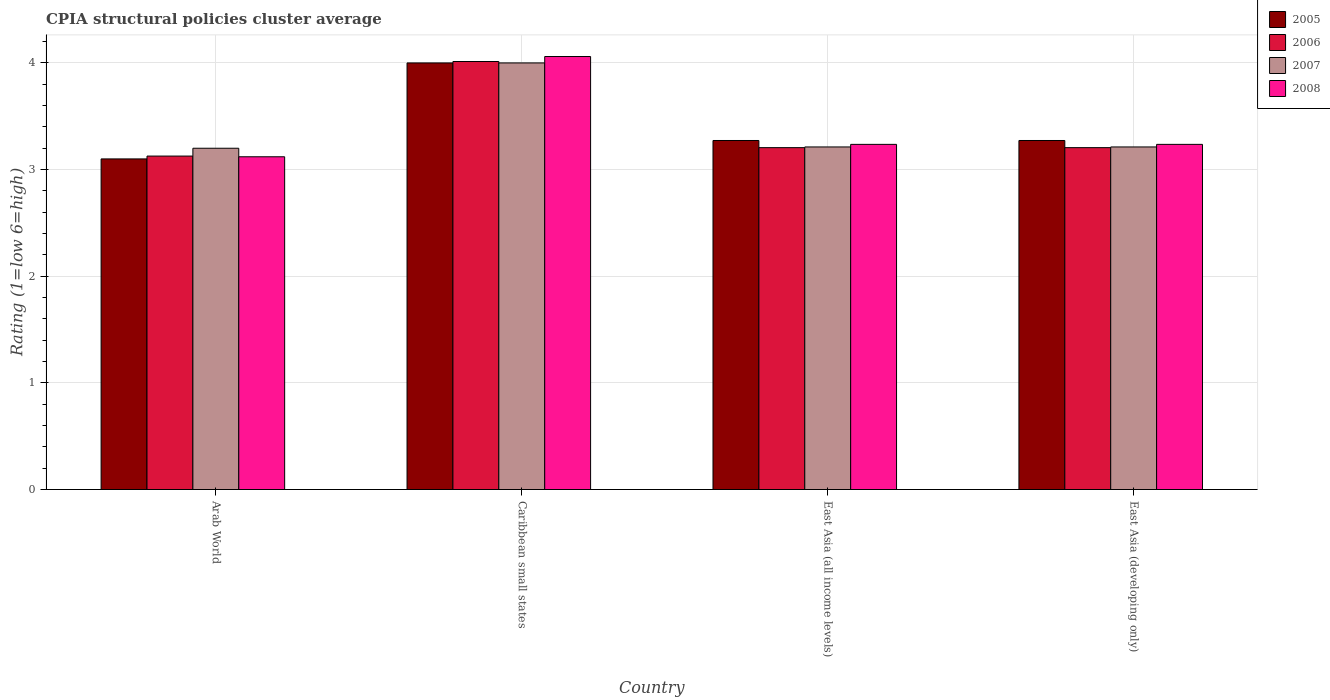How many groups of bars are there?
Ensure brevity in your answer.  4. Are the number of bars per tick equal to the number of legend labels?
Make the answer very short. Yes. Are the number of bars on each tick of the X-axis equal?
Your answer should be very brief. Yes. How many bars are there on the 3rd tick from the right?
Make the answer very short. 4. What is the label of the 2nd group of bars from the left?
Your response must be concise. Caribbean small states. In how many cases, is the number of bars for a given country not equal to the number of legend labels?
Your answer should be very brief. 0. What is the CPIA rating in 2008 in Arab World?
Give a very brief answer. 3.12. Across all countries, what is the maximum CPIA rating in 2007?
Offer a very short reply. 4. Across all countries, what is the minimum CPIA rating in 2006?
Your answer should be very brief. 3.13. In which country was the CPIA rating in 2007 maximum?
Your answer should be very brief. Caribbean small states. In which country was the CPIA rating in 2005 minimum?
Your answer should be compact. Arab World. What is the total CPIA rating in 2007 in the graph?
Give a very brief answer. 13.62. What is the difference between the CPIA rating in 2005 in East Asia (all income levels) and that in East Asia (developing only)?
Keep it short and to the point. 0. What is the difference between the CPIA rating in 2007 in Arab World and the CPIA rating in 2006 in Caribbean small states?
Give a very brief answer. -0.81. What is the average CPIA rating in 2008 per country?
Offer a terse response. 3.41. What is the difference between the CPIA rating of/in 2008 and CPIA rating of/in 2007 in Caribbean small states?
Your answer should be compact. 0.06. What is the ratio of the CPIA rating in 2006 in Caribbean small states to that in East Asia (all income levels)?
Your response must be concise. 1.25. Is the CPIA rating in 2005 in Arab World less than that in East Asia (developing only)?
Your answer should be compact. Yes. Is the difference between the CPIA rating in 2008 in Arab World and East Asia (all income levels) greater than the difference between the CPIA rating in 2007 in Arab World and East Asia (all income levels)?
Your response must be concise. No. What is the difference between the highest and the second highest CPIA rating in 2007?
Provide a short and direct response. -0.79. What is the difference between the highest and the lowest CPIA rating in 2005?
Provide a succinct answer. 0.9. Is it the case that in every country, the sum of the CPIA rating in 2008 and CPIA rating in 2006 is greater than the CPIA rating in 2007?
Your answer should be compact. Yes. How many bars are there?
Your answer should be compact. 16. What is the difference between two consecutive major ticks on the Y-axis?
Provide a succinct answer. 1. Are the values on the major ticks of Y-axis written in scientific E-notation?
Ensure brevity in your answer.  No. Does the graph contain any zero values?
Your answer should be compact. No. Does the graph contain grids?
Keep it short and to the point. Yes. Where does the legend appear in the graph?
Give a very brief answer. Top right. How many legend labels are there?
Give a very brief answer. 4. What is the title of the graph?
Your answer should be compact. CPIA structural policies cluster average. What is the label or title of the Y-axis?
Your answer should be compact. Rating (1=low 6=high). What is the Rating (1=low 6=high) of 2006 in Arab World?
Give a very brief answer. 3.13. What is the Rating (1=low 6=high) of 2008 in Arab World?
Offer a terse response. 3.12. What is the Rating (1=low 6=high) of 2005 in Caribbean small states?
Your answer should be compact. 4. What is the Rating (1=low 6=high) of 2006 in Caribbean small states?
Your response must be concise. 4.01. What is the Rating (1=low 6=high) of 2007 in Caribbean small states?
Provide a succinct answer. 4. What is the Rating (1=low 6=high) in 2008 in Caribbean small states?
Your answer should be very brief. 4.06. What is the Rating (1=low 6=high) of 2005 in East Asia (all income levels)?
Offer a very short reply. 3.27. What is the Rating (1=low 6=high) in 2006 in East Asia (all income levels)?
Provide a succinct answer. 3.21. What is the Rating (1=low 6=high) of 2007 in East Asia (all income levels)?
Offer a very short reply. 3.21. What is the Rating (1=low 6=high) in 2008 in East Asia (all income levels)?
Keep it short and to the point. 3.24. What is the Rating (1=low 6=high) in 2005 in East Asia (developing only)?
Ensure brevity in your answer.  3.27. What is the Rating (1=low 6=high) in 2006 in East Asia (developing only)?
Ensure brevity in your answer.  3.21. What is the Rating (1=low 6=high) of 2007 in East Asia (developing only)?
Provide a short and direct response. 3.21. What is the Rating (1=low 6=high) in 2008 in East Asia (developing only)?
Your answer should be compact. 3.24. Across all countries, what is the maximum Rating (1=low 6=high) in 2006?
Keep it short and to the point. 4.01. Across all countries, what is the maximum Rating (1=low 6=high) in 2008?
Ensure brevity in your answer.  4.06. Across all countries, what is the minimum Rating (1=low 6=high) of 2005?
Offer a very short reply. 3.1. Across all countries, what is the minimum Rating (1=low 6=high) in 2006?
Your answer should be very brief. 3.13. Across all countries, what is the minimum Rating (1=low 6=high) of 2007?
Ensure brevity in your answer.  3.2. Across all countries, what is the minimum Rating (1=low 6=high) in 2008?
Your response must be concise. 3.12. What is the total Rating (1=low 6=high) of 2005 in the graph?
Provide a short and direct response. 13.65. What is the total Rating (1=low 6=high) in 2006 in the graph?
Offer a terse response. 13.55. What is the total Rating (1=low 6=high) in 2007 in the graph?
Offer a very short reply. 13.62. What is the total Rating (1=low 6=high) of 2008 in the graph?
Provide a succinct answer. 13.65. What is the difference between the Rating (1=low 6=high) in 2005 in Arab World and that in Caribbean small states?
Offer a terse response. -0.9. What is the difference between the Rating (1=low 6=high) of 2006 in Arab World and that in Caribbean small states?
Make the answer very short. -0.89. What is the difference between the Rating (1=low 6=high) of 2007 in Arab World and that in Caribbean small states?
Provide a short and direct response. -0.8. What is the difference between the Rating (1=low 6=high) of 2008 in Arab World and that in Caribbean small states?
Provide a short and direct response. -0.94. What is the difference between the Rating (1=low 6=high) in 2005 in Arab World and that in East Asia (all income levels)?
Give a very brief answer. -0.17. What is the difference between the Rating (1=low 6=high) of 2006 in Arab World and that in East Asia (all income levels)?
Offer a very short reply. -0.08. What is the difference between the Rating (1=low 6=high) in 2007 in Arab World and that in East Asia (all income levels)?
Ensure brevity in your answer.  -0.01. What is the difference between the Rating (1=low 6=high) of 2008 in Arab World and that in East Asia (all income levels)?
Give a very brief answer. -0.12. What is the difference between the Rating (1=low 6=high) of 2005 in Arab World and that in East Asia (developing only)?
Provide a short and direct response. -0.17. What is the difference between the Rating (1=low 6=high) in 2006 in Arab World and that in East Asia (developing only)?
Make the answer very short. -0.08. What is the difference between the Rating (1=low 6=high) in 2007 in Arab World and that in East Asia (developing only)?
Provide a short and direct response. -0.01. What is the difference between the Rating (1=low 6=high) in 2008 in Arab World and that in East Asia (developing only)?
Your answer should be very brief. -0.12. What is the difference between the Rating (1=low 6=high) in 2005 in Caribbean small states and that in East Asia (all income levels)?
Make the answer very short. 0.73. What is the difference between the Rating (1=low 6=high) in 2006 in Caribbean small states and that in East Asia (all income levels)?
Your response must be concise. 0.81. What is the difference between the Rating (1=low 6=high) of 2007 in Caribbean small states and that in East Asia (all income levels)?
Ensure brevity in your answer.  0.79. What is the difference between the Rating (1=low 6=high) in 2008 in Caribbean small states and that in East Asia (all income levels)?
Make the answer very short. 0.82. What is the difference between the Rating (1=low 6=high) of 2005 in Caribbean small states and that in East Asia (developing only)?
Your answer should be compact. 0.73. What is the difference between the Rating (1=low 6=high) in 2006 in Caribbean small states and that in East Asia (developing only)?
Ensure brevity in your answer.  0.81. What is the difference between the Rating (1=low 6=high) of 2007 in Caribbean small states and that in East Asia (developing only)?
Give a very brief answer. 0.79. What is the difference between the Rating (1=low 6=high) of 2008 in Caribbean small states and that in East Asia (developing only)?
Your answer should be compact. 0.82. What is the difference between the Rating (1=low 6=high) in 2005 in East Asia (all income levels) and that in East Asia (developing only)?
Ensure brevity in your answer.  0. What is the difference between the Rating (1=low 6=high) of 2006 in East Asia (all income levels) and that in East Asia (developing only)?
Keep it short and to the point. 0. What is the difference between the Rating (1=low 6=high) of 2007 in East Asia (all income levels) and that in East Asia (developing only)?
Keep it short and to the point. 0. What is the difference between the Rating (1=low 6=high) of 2005 in Arab World and the Rating (1=low 6=high) of 2006 in Caribbean small states?
Provide a short and direct response. -0.91. What is the difference between the Rating (1=low 6=high) of 2005 in Arab World and the Rating (1=low 6=high) of 2007 in Caribbean small states?
Provide a succinct answer. -0.9. What is the difference between the Rating (1=low 6=high) of 2005 in Arab World and the Rating (1=low 6=high) of 2008 in Caribbean small states?
Make the answer very short. -0.96. What is the difference between the Rating (1=low 6=high) of 2006 in Arab World and the Rating (1=low 6=high) of 2007 in Caribbean small states?
Offer a very short reply. -0.87. What is the difference between the Rating (1=low 6=high) of 2006 in Arab World and the Rating (1=low 6=high) of 2008 in Caribbean small states?
Provide a short and direct response. -0.93. What is the difference between the Rating (1=low 6=high) of 2007 in Arab World and the Rating (1=low 6=high) of 2008 in Caribbean small states?
Give a very brief answer. -0.86. What is the difference between the Rating (1=low 6=high) in 2005 in Arab World and the Rating (1=low 6=high) in 2006 in East Asia (all income levels)?
Your answer should be compact. -0.11. What is the difference between the Rating (1=low 6=high) in 2005 in Arab World and the Rating (1=low 6=high) in 2007 in East Asia (all income levels)?
Ensure brevity in your answer.  -0.11. What is the difference between the Rating (1=low 6=high) in 2005 in Arab World and the Rating (1=low 6=high) in 2008 in East Asia (all income levels)?
Give a very brief answer. -0.14. What is the difference between the Rating (1=low 6=high) in 2006 in Arab World and the Rating (1=low 6=high) in 2007 in East Asia (all income levels)?
Make the answer very short. -0.09. What is the difference between the Rating (1=low 6=high) in 2006 in Arab World and the Rating (1=low 6=high) in 2008 in East Asia (all income levels)?
Your answer should be very brief. -0.11. What is the difference between the Rating (1=low 6=high) in 2007 in Arab World and the Rating (1=low 6=high) in 2008 in East Asia (all income levels)?
Offer a terse response. -0.04. What is the difference between the Rating (1=low 6=high) of 2005 in Arab World and the Rating (1=low 6=high) of 2006 in East Asia (developing only)?
Your answer should be compact. -0.11. What is the difference between the Rating (1=low 6=high) in 2005 in Arab World and the Rating (1=low 6=high) in 2007 in East Asia (developing only)?
Offer a terse response. -0.11. What is the difference between the Rating (1=low 6=high) of 2005 in Arab World and the Rating (1=low 6=high) of 2008 in East Asia (developing only)?
Your answer should be very brief. -0.14. What is the difference between the Rating (1=low 6=high) in 2006 in Arab World and the Rating (1=low 6=high) in 2007 in East Asia (developing only)?
Offer a terse response. -0.09. What is the difference between the Rating (1=low 6=high) in 2006 in Arab World and the Rating (1=low 6=high) in 2008 in East Asia (developing only)?
Offer a very short reply. -0.11. What is the difference between the Rating (1=low 6=high) of 2007 in Arab World and the Rating (1=low 6=high) of 2008 in East Asia (developing only)?
Provide a short and direct response. -0.04. What is the difference between the Rating (1=low 6=high) of 2005 in Caribbean small states and the Rating (1=low 6=high) of 2006 in East Asia (all income levels)?
Your answer should be compact. 0.79. What is the difference between the Rating (1=low 6=high) in 2005 in Caribbean small states and the Rating (1=low 6=high) in 2007 in East Asia (all income levels)?
Offer a terse response. 0.79. What is the difference between the Rating (1=low 6=high) of 2005 in Caribbean small states and the Rating (1=low 6=high) of 2008 in East Asia (all income levels)?
Offer a very short reply. 0.76. What is the difference between the Rating (1=low 6=high) of 2006 in Caribbean small states and the Rating (1=low 6=high) of 2007 in East Asia (all income levels)?
Provide a short and direct response. 0.8. What is the difference between the Rating (1=low 6=high) in 2006 in Caribbean small states and the Rating (1=low 6=high) in 2008 in East Asia (all income levels)?
Your answer should be very brief. 0.78. What is the difference between the Rating (1=low 6=high) in 2007 in Caribbean small states and the Rating (1=low 6=high) in 2008 in East Asia (all income levels)?
Give a very brief answer. 0.76. What is the difference between the Rating (1=low 6=high) in 2005 in Caribbean small states and the Rating (1=low 6=high) in 2006 in East Asia (developing only)?
Your answer should be very brief. 0.79. What is the difference between the Rating (1=low 6=high) of 2005 in Caribbean small states and the Rating (1=low 6=high) of 2007 in East Asia (developing only)?
Keep it short and to the point. 0.79. What is the difference between the Rating (1=low 6=high) of 2005 in Caribbean small states and the Rating (1=low 6=high) of 2008 in East Asia (developing only)?
Keep it short and to the point. 0.76. What is the difference between the Rating (1=low 6=high) in 2006 in Caribbean small states and the Rating (1=low 6=high) in 2007 in East Asia (developing only)?
Make the answer very short. 0.8. What is the difference between the Rating (1=low 6=high) of 2006 in Caribbean small states and the Rating (1=low 6=high) of 2008 in East Asia (developing only)?
Provide a succinct answer. 0.78. What is the difference between the Rating (1=low 6=high) of 2007 in Caribbean small states and the Rating (1=low 6=high) of 2008 in East Asia (developing only)?
Provide a short and direct response. 0.76. What is the difference between the Rating (1=low 6=high) in 2005 in East Asia (all income levels) and the Rating (1=low 6=high) in 2006 in East Asia (developing only)?
Your answer should be very brief. 0.07. What is the difference between the Rating (1=low 6=high) of 2005 in East Asia (all income levels) and the Rating (1=low 6=high) of 2007 in East Asia (developing only)?
Ensure brevity in your answer.  0.06. What is the difference between the Rating (1=low 6=high) of 2005 in East Asia (all income levels) and the Rating (1=low 6=high) of 2008 in East Asia (developing only)?
Your response must be concise. 0.04. What is the difference between the Rating (1=low 6=high) in 2006 in East Asia (all income levels) and the Rating (1=low 6=high) in 2007 in East Asia (developing only)?
Your answer should be very brief. -0.01. What is the difference between the Rating (1=low 6=high) of 2006 in East Asia (all income levels) and the Rating (1=low 6=high) of 2008 in East Asia (developing only)?
Offer a very short reply. -0.03. What is the difference between the Rating (1=low 6=high) in 2007 in East Asia (all income levels) and the Rating (1=low 6=high) in 2008 in East Asia (developing only)?
Your answer should be compact. -0.02. What is the average Rating (1=low 6=high) in 2005 per country?
Offer a terse response. 3.41. What is the average Rating (1=low 6=high) of 2006 per country?
Provide a succinct answer. 3.39. What is the average Rating (1=low 6=high) in 2007 per country?
Offer a very short reply. 3.41. What is the average Rating (1=low 6=high) in 2008 per country?
Ensure brevity in your answer.  3.41. What is the difference between the Rating (1=low 6=high) of 2005 and Rating (1=low 6=high) of 2006 in Arab World?
Offer a very short reply. -0.03. What is the difference between the Rating (1=low 6=high) in 2005 and Rating (1=low 6=high) in 2008 in Arab World?
Your response must be concise. -0.02. What is the difference between the Rating (1=low 6=high) in 2006 and Rating (1=low 6=high) in 2007 in Arab World?
Offer a terse response. -0.07. What is the difference between the Rating (1=low 6=high) of 2006 and Rating (1=low 6=high) of 2008 in Arab World?
Your answer should be compact. 0.01. What is the difference between the Rating (1=low 6=high) in 2007 and Rating (1=low 6=high) in 2008 in Arab World?
Keep it short and to the point. 0.08. What is the difference between the Rating (1=low 6=high) in 2005 and Rating (1=low 6=high) in 2006 in Caribbean small states?
Ensure brevity in your answer.  -0.01. What is the difference between the Rating (1=low 6=high) of 2005 and Rating (1=low 6=high) of 2008 in Caribbean small states?
Ensure brevity in your answer.  -0.06. What is the difference between the Rating (1=low 6=high) in 2006 and Rating (1=low 6=high) in 2007 in Caribbean small states?
Provide a short and direct response. 0.01. What is the difference between the Rating (1=low 6=high) of 2006 and Rating (1=low 6=high) of 2008 in Caribbean small states?
Keep it short and to the point. -0.05. What is the difference between the Rating (1=low 6=high) of 2007 and Rating (1=low 6=high) of 2008 in Caribbean small states?
Make the answer very short. -0.06. What is the difference between the Rating (1=low 6=high) in 2005 and Rating (1=low 6=high) in 2006 in East Asia (all income levels)?
Offer a terse response. 0.07. What is the difference between the Rating (1=low 6=high) in 2005 and Rating (1=low 6=high) in 2007 in East Asia (all income levels)?
Your response must be concise. 0.06. What is the difference between the Rating (1=low 6=high) of 2005 and Rating (1=low 6=high) of 2008 in East Asia (all income levels)?
Your response must be concise. 0.04. What is the difference between the Rating (1=low 6=high) of 2006 and Rating (1=low 6=high) of 2007 in East Asia (all income levels)?
Offer a terse response. -0.01. What is the difference between the Rating (1=low 6=high) in 2006 and Rating (1=low 6=high) in 2008 in East Asia (all income levels)?
Your answer should be compact. -0.03. What is the difference between the Rating (1=low 6=high) in 2007 and Rating (1=low 6=high) in 2008 in East Asia (all income levels)?
Give a very brief answer. -0.02. What is the difference between the Rating (1=low 6=high) in 2005 and Rating (1=low 6=high) in 2006 in East Asia (developing only)?
Ensure brevity in your answer.  0.07. What is the difference between the Rating (1=low 6=high) in 2005 and Rating (1=low 6=high) in 2007 in East Asia (developing only)?
Make the answer very short. 0.06. What is the difference between the Rating (1=low 6=high) of 2005 and Rating (1=low 6=high) of 2008 in East Asia (developing only)?
Your answer should be compact. 0.04. What is the difference between the Rating (1=low 6=high) in 2006 and Rating (1=low 6=high) in 2007 in East Asia (developing only)?
Your answer should be compact. -0.01. What is the difference between the Rating (1=low 6=high) in 2006 and Rating (1=low 6=high) in 2008 in East Asia (developing only)?
Keep it short and to the point. -0.03. What is the difference between the Rating (1=low 6=high) in 2007 and Rating (1=low 6=high) in 2008 in East Asia (developing only)?
Provide a succinct answer. -0.02. What is the ratio of the Rating (1=low 6=high) in 2005 in Arab World to that in Caribbean small states?
Give a very brief answer. 0.78. What is the ratio of the Rating (1=low 6=high) of 2006 in Arab World to that in Caribbean small states?
Your response must be concise. 0.78. What is the ratio of the Rating (1=low 6=high) in 2007 in Arab World to that in Caribbean small states?
Keep it short and to the point. 0.8. What is the ratio of the Rating (1=low 6=high) in 2008 in Arab World to that in Caribbean small states?
Offer a very short reply. 0.77. What is the ratio of the Rating (1=low 6=high) in 2005 in Arab World to that in East Asia (all income levels)?
Offer a terse response. 0.95. What is the ratio of the Rating (1=low 6=high) in 2006 in Arab World to that in East Asia (all income levels)?
Provide a short and direct response. 0.98. What is the ratio of the Rating (1=low 6=high) of 2007 in Arab World to that in East Asia (all income levels)?
Make the answer very short. 1. What is the ratio of the Rating (1=low 6=high) in 2008 in Arab World to that in East Asia (all income levels)?
Ensure brevity in your answer.  0.96. What is the ratio of the Rating (1=low 6=high) in 2005 in Arab World to that in East Asia (developing only)?
Your response must be concise. 0.95. What is the ratio of the Rating (1=low 6=high) of 2006 in Arab World to that in East Asia (developing only)?
Your answer should be compact. 0.98. What is the ratio of the Rating (1=low 6=high) in 2007 in Arab World to that in East Asia (developing only)?
Provide a succinct answer. 1. What is the ratio of the Rating (1=low 6=high) in 2005 in Caribbean small states to that in East Asia (all income levels)?
Give a very brief answer. 1.22. What is the ratio of the Rating (1=low 6=high) in 2006 in Caribbean small states to that in East Asia (all income levels)?
Offer a very short reply. 1.25. What is the ratio of the Rating (1=low 6=high) in 2007 in Caribbean small states to that in East Asia (all income levels)?
Keep it short and to the point. 1.25. What is the ratio of the Rating (1=low 6=high) of 2008 in Caribbean small states to that in East Asia (all income levels)?
Your answer should be compact. 1.25. What is the ratio of the Rating (1=low 6=high) in 2005 in Caribbean small states to that in East Asia (developing only)?
Offer a very short reply. 1.22. What is the ratio of the Rating (1=low 6=high) in 2006 in Caribbean small states to that in East Asia (developing only)?
Your answer should be very brief. 1.25. What is the ratio of the Rating (1=low 6=high) of 2007 in Caribbean small states to that in East Asia (developing only)?
Provide a short and direct response. 1.25. What is the ratio of the Rating (1=low 6=high) in 2008 in Caribbean small states to that in East Asia (developing only)?
Your answer should be very brief. 1.25. What is the ratio of the Rating (1=low 6=high) in 2005 in East Asia (all income levels) to that in East Asia (developing only)?
Your response must be concise. 1. What is the ratio of the Rating (1=low 6=high) of 2006 in East Asia (all income levels) to that in East Asia (developing only)?
Your answer should be very brief. 1. What is the difference between the highest and the second highest Rating (1=low 6=high) in 2005?
Your answer should be compact. 0.73. What is the difference between the highest and the second highest Rating (1=low 6=high) of 2006?
Provide a short and direct response. 0.81. What is the difference between the highest and the second highest Rating (1=low 6=high) in 2007?
Offer a very short reply. 0.79. What is the difference between the highest and the second highest Rating (1=low 6=high) of 2008?
Make the answer very short. 0.82. What is the difference between the highest and the lowest Rating (1=low 6=high) of 2005?
Make the answer very short. 0.9. What is the difference between the highest and the lowest Rating (1=low 6=high) of 2006?
Give a very brief answer. 0.89. What is the difference between the highest and the lowest Rating (1=low 6=high) in 2008?
Offer a terse response. 0.94. 